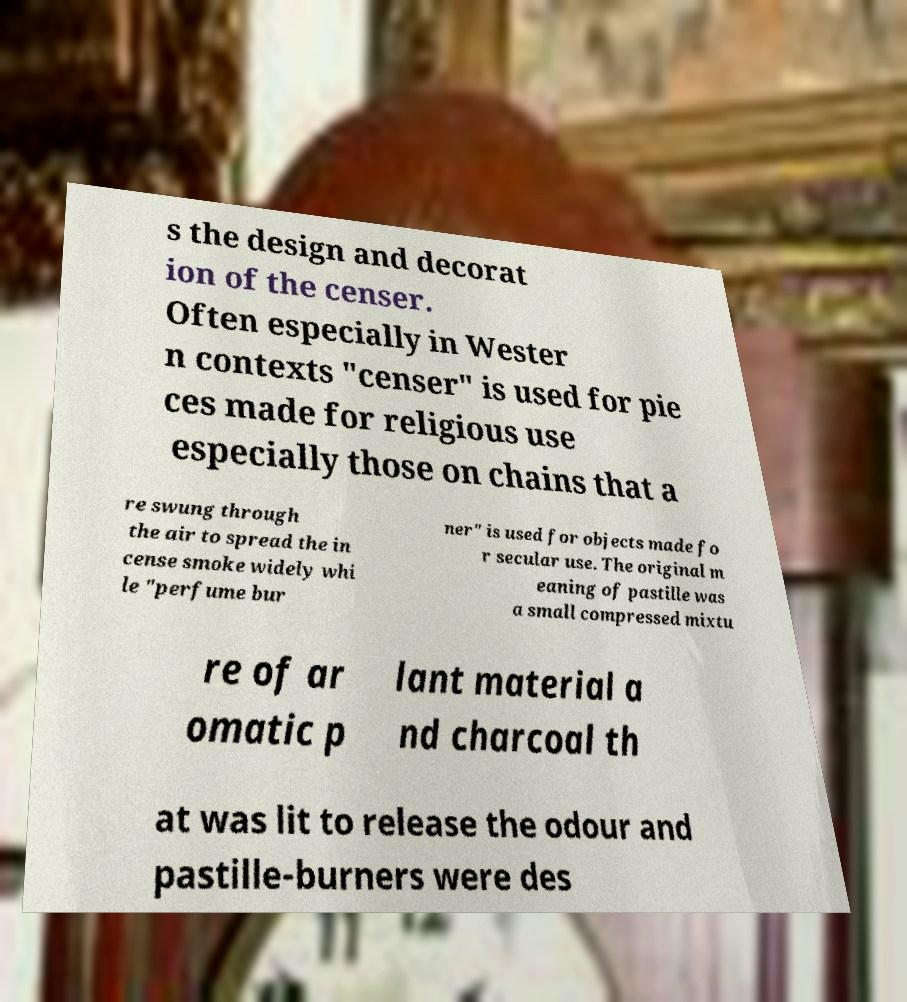There's text embedded in this image that I need extracted. Can you transcribe it verbatim? s the design and decorat ion of the censer. Often especially in Wester n contexts "censer" is used for pie ces made for religious use especially those on chains that a re swung through the air to spread the in cense smoke widely whi le "perfume bur ner" is used for objects made fo r secular use. The original m eaning of pastille was a small compressed mixtu re of ar omatic p lant material a nd charcoal th at was lit to release the odour and pastille-burners were des 